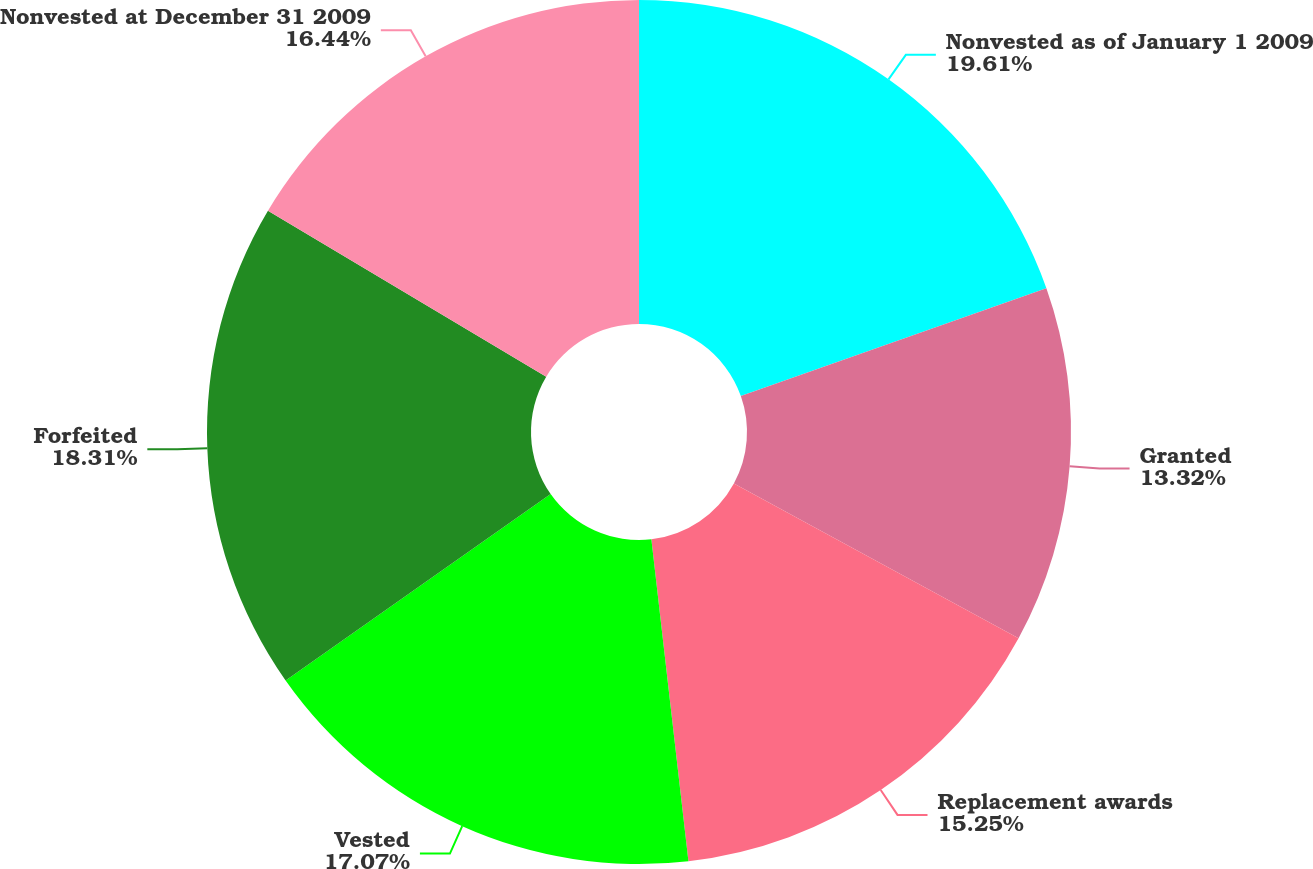<chart> <loc_0><loc_0><loc_500><loc_500><pie_chart><fcel>Nonvested as of January 1 2009<fcel>Granted<fcel>Replacement awards<fcel>Vested<fcel>Forfeited<fcel>Nonvested at December 31 2009<nl><fcel>19.6%<fcel>13.32%<fcel>15.25%<fcel>17.07%<fcel>18.31%<fcel>16.44%<nl></chart> 